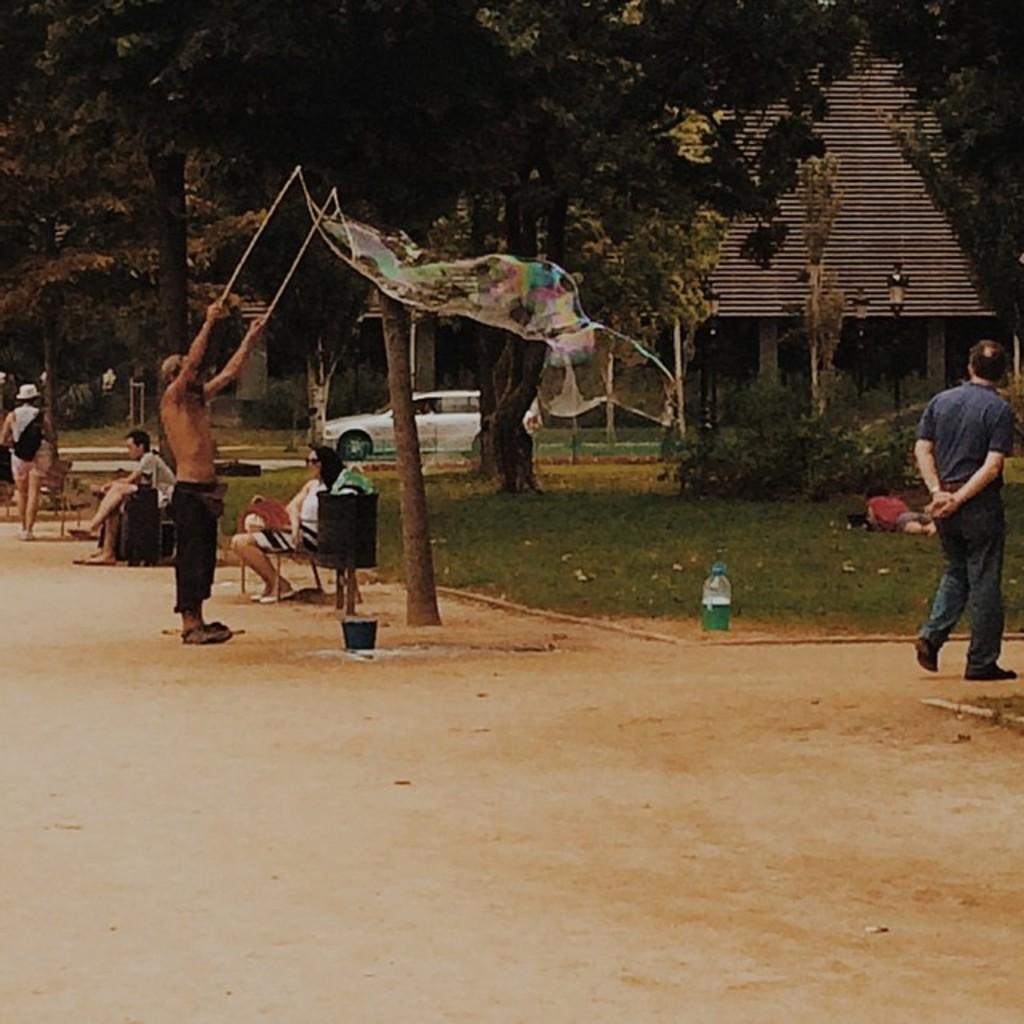Can you describe this image briefly? In this image we can see people, chairs, bottle, trees, grass and other objects. In the background of the image there is a building, vehicle, poles and other objects. At the bottom of the image there is the ground. 